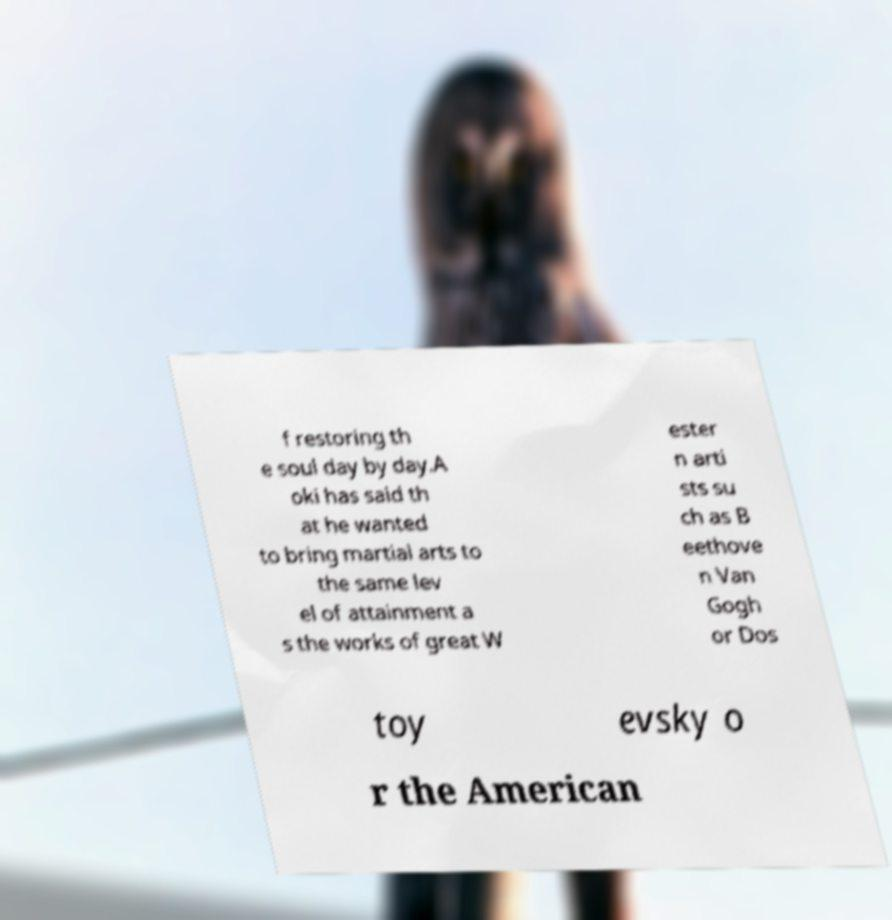Please identify and transcribe the text found in this image. f restoring th e soul day by day.A oki has said th at he wanted to bring martial arts to the same lev el of attainment a s the works of great W ester n arti sts su ch as B eethove n Van Gogh or Dos toy evsky o r the American 